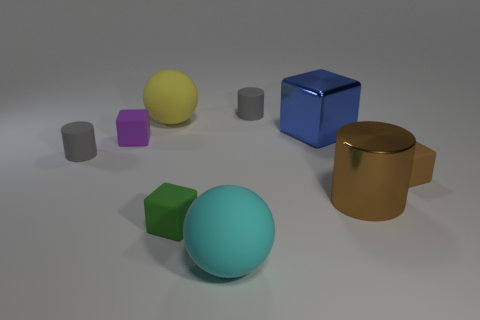Is the number of large objects that are to the left of the large yellow ball less than the number of small yellow metallic balls?
Your response must be concise. No. What shape is the tiny gray object that is to the left of the tiny purple cube?
Keep it short and to the point. Cylinder. What is the shape of the tiny gray thing that is in front of the small matte thing behind the big sphere that is behind the small brown block?
Your response must be concise. Cylinder. What number of things are tiny cyan spheres or large metal blocks?
Make the answer very short. 1. Does the big rubber thing to the right of the big yellow thing have the same shape as the yellow rubber object that is on the right side of the purple matte cube?
Your answer should be compact. Yes. How many objects are right of the yellow object and to the left of the big blue thing?
Provide a short and direct response. 3. What number of other objects are there of the same size as the green matte cube?
Ensure brevity in your answer.  4. There is a block that is both to the right of the big cyan rubber thing and left of the metallic cylinder; what material is it?
Give a very brief answer. Metal. There is a big shiny cylinder; is it the same color as the small block that is on the right side of the small green matte object?
Offer a very short reply. Yes. What is the size of the green rubber object that is the same shape as the small brown object?
Your response must be concise. Small. 